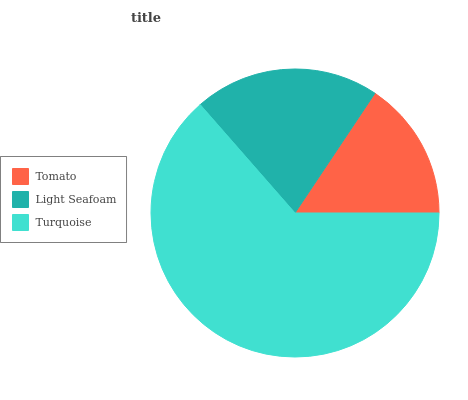Is Tomato the minimum?
Answer yes or no. Yes. Is Turquoise the maximum?
Answer yes or no. Yes. Is Light Seafoam the minimum?
Answer yes or no. No. Is Light Seafoam the maximum?
Answer yes or no. No. Is Light Seafoam greater than Tomato?
Answer yes or no. Yes. Is Tomato less than Light Seafoam?
Answer yes or no. Yes. Is Tomato greater than Light Seafoam?
Answer yes or no. No. Is Light Seafoam less than Tomato?
Answer yes or no. No. Is Light Seafoam the high median?
Answer yes or no. Yes. Is Light Seafoam the low median?
Answer yes or no. Yes. Is Turquoise the high median?
Answer yes or no. No. Is Turquoise the low median?
Answer yes or no. No. 